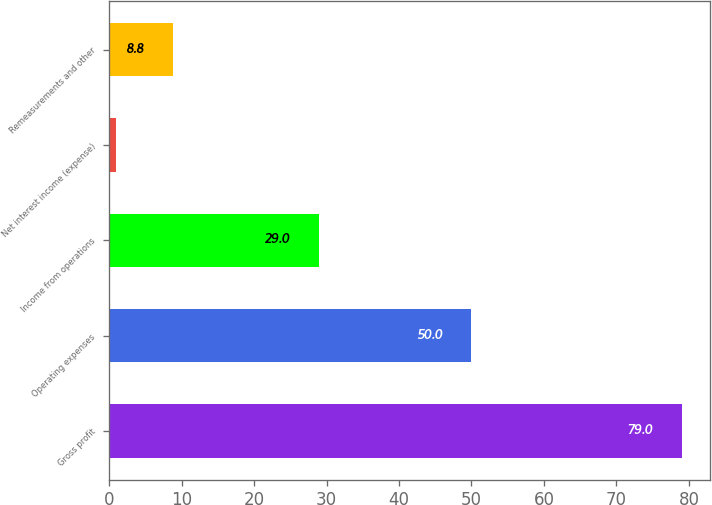Convert chart. <chart><loc_0><loc_0><loc_500><loc_500><bar_chart><fcel>Gross profit<fcel>Operating expenses<fcel>Income from operations<fcel>Net interest income (expense)<fcel>Remeasurements and other<nl><fcel>79<fcel>50<fcel>29<fcel>1<fcel>8.8<nl></chart> 